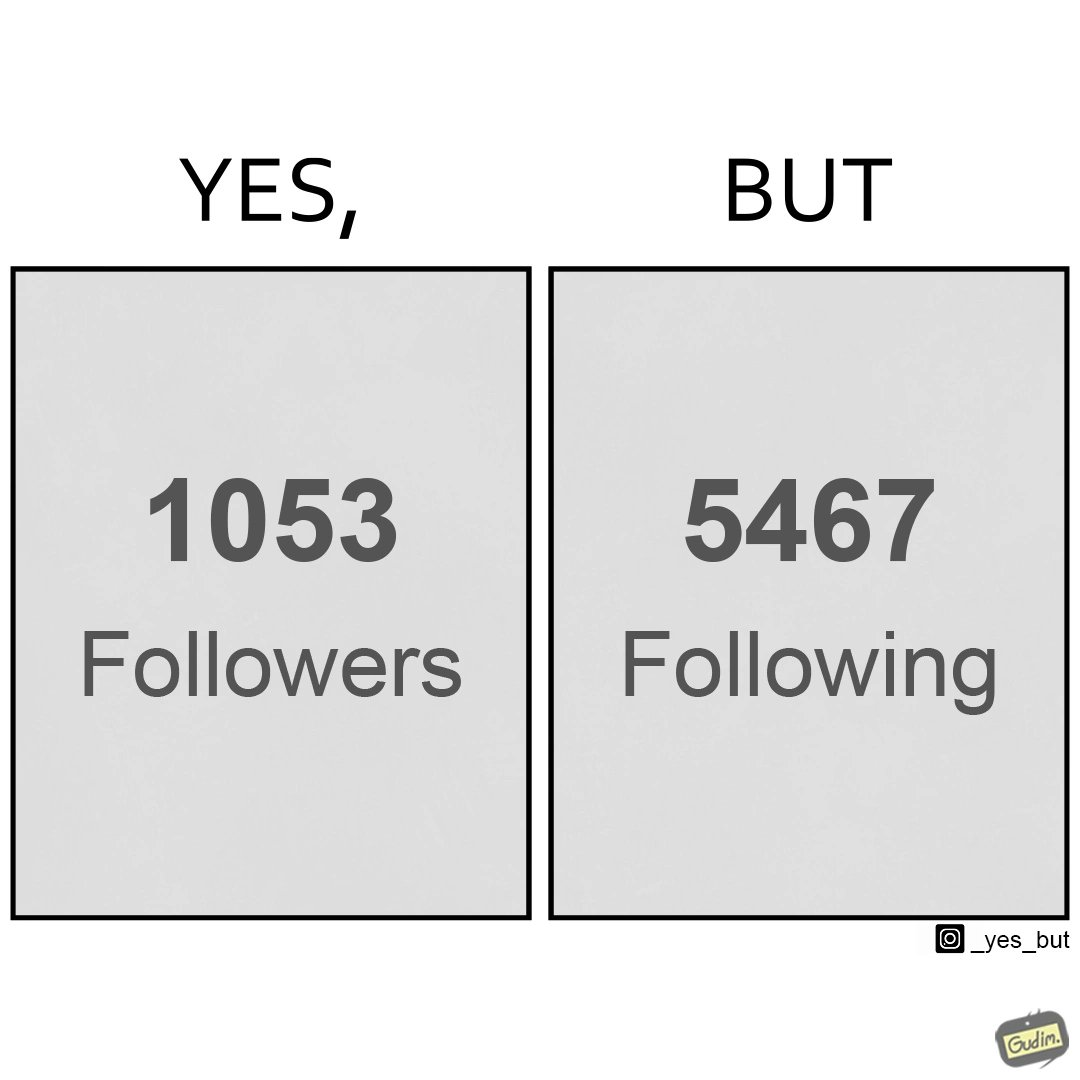Would you classify this image as satirical? Yes, this image is satirical. 